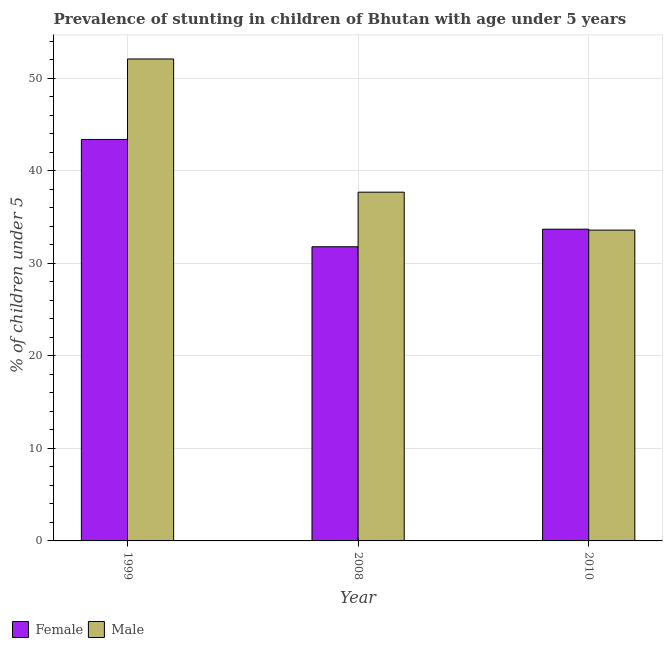Are the number of bars per tick equal to the number of legend labels?
Your response must be concise. Yes. Are the number of bars on each tick of the X-axis equal?
Make the answer very short. Yes. How many bars are there on the 3rd tick from the right?
Offer a very short reply. 2. What is the label of the 1st group of bars from the left?
Your answer should be compact. 1999. In how many cases, is the number of bars for a given year not equal to the number of legend labels?
Your answer should be very brief. 0. What is the percentage of stunted female children in 1999?
Offer a terse response. 43.4. Across all years, what is the maximum percentage of stunted female children?
Give a very brief answer. 43.4. Across all years, what is the minimum percentage of stunted male children?
Provide a short and direct response. 33.6. In which year was the percentage of stunted male children maximum?
Offer a terse response. 1999. In which year was the percentage of stunted male children minimum?
Offer a very short reply. 2010. What is the total percentage of stunted female children in the graph?
Offer a very short reply. 108.9. What is the difference between the percentage of stunted female children in 2008 and that in 2010?
Provide a short and direct response. -1.9. What is the difference between the percentage of stunted male children in 2008 and the percentage of stunted female children in 2010?
Your response must be concise. 4.1. What is the average percentage of stunted female children per year?
Give a very brief answer. 36.3. In the year 2010, what is the difference between the percentage of stunted female children and percentage of stunted male children?
Give a very brief answer. 0. What is the ratio of the percentage of stunted male children in 2008 to that in 2010?
Your answer should be very brief. 1.12. What is the difference between the highest and the second highest percentage of stunted male children?
Provide a succinct answer. 14.4. What is the difference between the highest and the lowest percentage of stunted male children?
Provide a succinct answer. 18.5. Is the sum of the percentage of stunted male children in 2008 and 2010 greater than the maximum percentage of stunted female children across all years?
Offer a very short reply. Yes. What does the 2nd bar from the right in 1999 represents?
Your answer should be very brief. Female. Are all the bars in the graph horizontal?
Offer a terse response. No. Does the graph contain any zero values?
Offer a terse response. No. Where does the legend appear in the graph?
Your answer should be compact. Bottom left. How many legend labels are there?
Make the answer very short. 2. What is the title of the graph?
Make the answer very short. Prevalence of stunting in children of Bhutan with age under 5 years. Does "International Visitors" appear as one of the legend labels in the graph?
Ensure brevity in your answer.  No. What is the label or title of the X-axis?
Keep it short and to the point. Year. What is the label or title of the Y-axis?
Provide a short and direct response.  % of children under 5. What is the  % of children under 5 of Female in 1999?
Provide a succinct answer. 43.4. What is the  % of children under 5 in Male in 1999?
Offer a terse response. 52.1. What is the  % of children under 5 of Female in 2008?
Offer a terse response. 31.8. What is the  % of children under 5 of Male in 2008?
Your answer should be compact. 37.7. What is the  % of children under 5 in Female in 2010?
Offer a terse response. 33.7. What is the  % of children under 5 in Male in 2010?
Keep it short and to the point. 33.6. Across all years, what is the maximum  % of children under 5 of Female?
Offer a very short reply. 43.4. Across all years, what is the maximum  % of children under 5 in Male?
Give a very brief answer. 52.1. Across all years, what is the minimum  % of children under 5 in Female?
Make the answer very short. 31.8. Across all years, what is the minimum  % of children under 5 in Male?
Keep it short and to the point. 33.6. What is the total  % of children under 5 of Female in the graph?
Offer a terse response. 108.9. What is the total  % of children under 5 of Male in the graph?
Make the answer very short. 123.4. What is the difference between the  % of children under 5 in Female in 1999 and that in 2008?
Your answer should be very brief. 11.6. What is the difference between the  % of children under 5 of Male in 1999 and that in 2008?
Your answer should be compact. 14.4. What is the difference between the  % of children under 5 in Male in 2008 and that in 2010?
Provide a succinct answer. 4.1. What is the difference between the  % of children under 5 of Female in 1999 and the  % of children under 5 of Male in 2010?
Offer a terse response. 9.8. What is the average  % of children under 5 of Female per year?
Offer a very short reply. 36.3. What is the average  % of children under 5 in Male per year?
Ensure brevity in your answer.  41.13. In the year 2010, what is the difference between the  % of children under 5 of Female and  % of children under 5 of Male?
Keep it short and to the point. 0.1. What is the ratio of the  % of children under 5 in Female in 1999 to that in 2008?
Your response must be concise. 1.36. What is the ratio of the  % of children under 5 in Male in 1999 to that in 2008?
Provide a short and direct response. 1.38. What is the ratio of the  % of children under 5 of Female in 1999 to that in 2010?
Make the answer very short. 1.29. What is the ratio of the  % of children under 5 of Male in 1999 to that in 2010?
Offer a terse response. 1.55. What is the ratio of the  % of children under 5 of Female in 2008 to that in 2010?
Ensure brevity in your answer.  0.94. What is the ratio of the  % of children under 5 of Male in 2008 to that in 2010?
Make the answer very short. 1.12. What is the difference between the highest and the second highest  % of children under 5 of Female?
Offer a very short reply. 9.7. What is the difference between the highest and the lowest  % of children under 5 of Male?
Your answer should be compact. 18.5. 